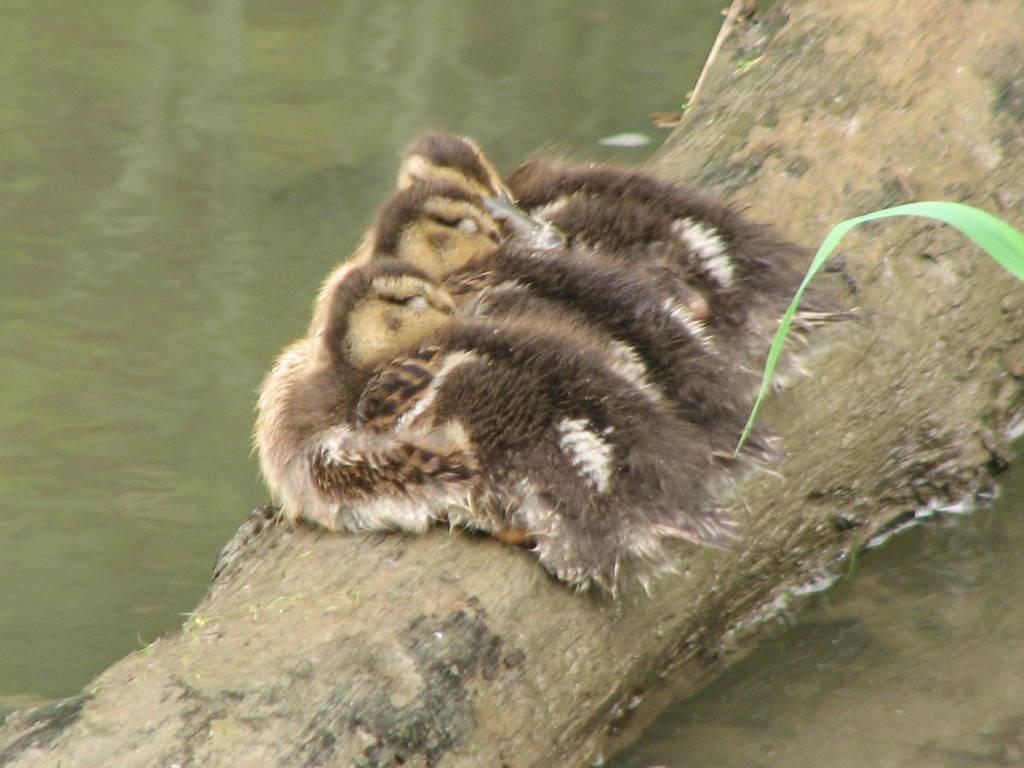Please provide a concise description of this image. In this picture we can see birds on the wooden platform. We can see water and leaf. 